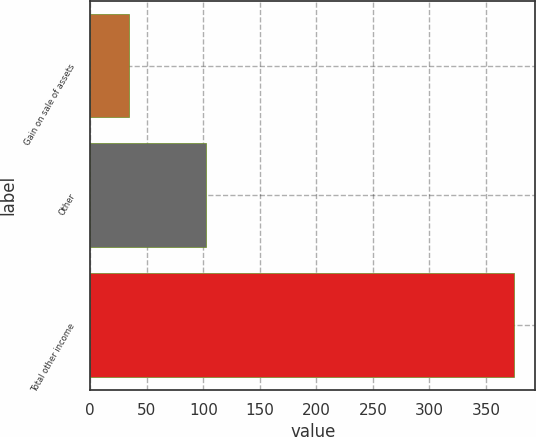<chart> <loc_0><loc_0><loc_500><loc_500><bar_chart><fcel>Gain on sale of assets<fcel>Other<fcel>Total other income<nl><fcel>34<fcel>102<fcel>375<nl></chart> 